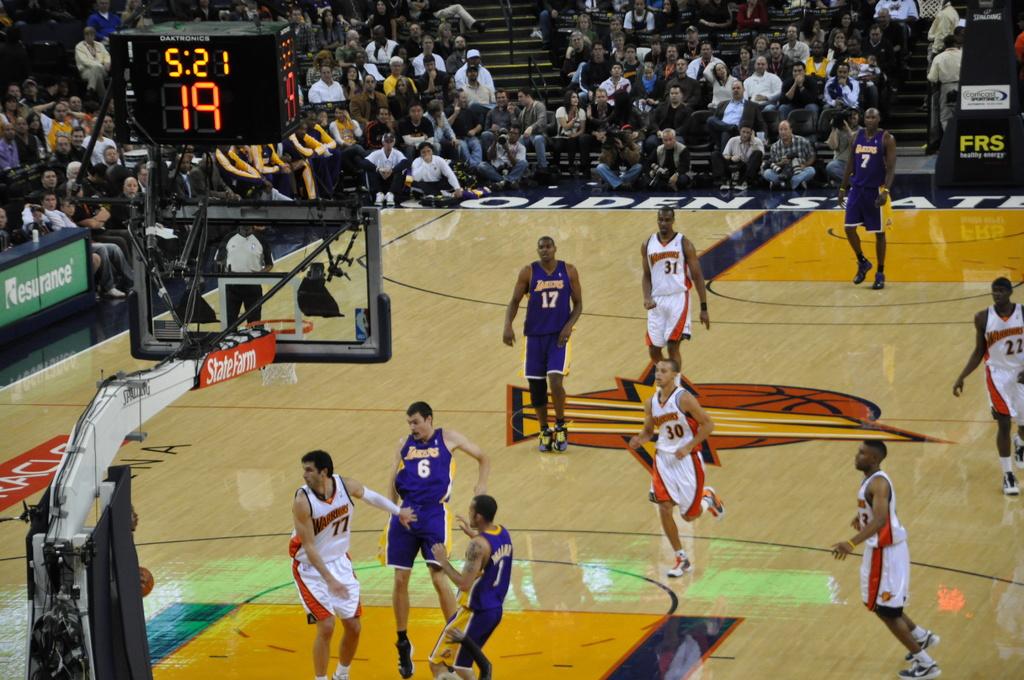What time does the clock say?
Offer a very short reply. 5:21. 